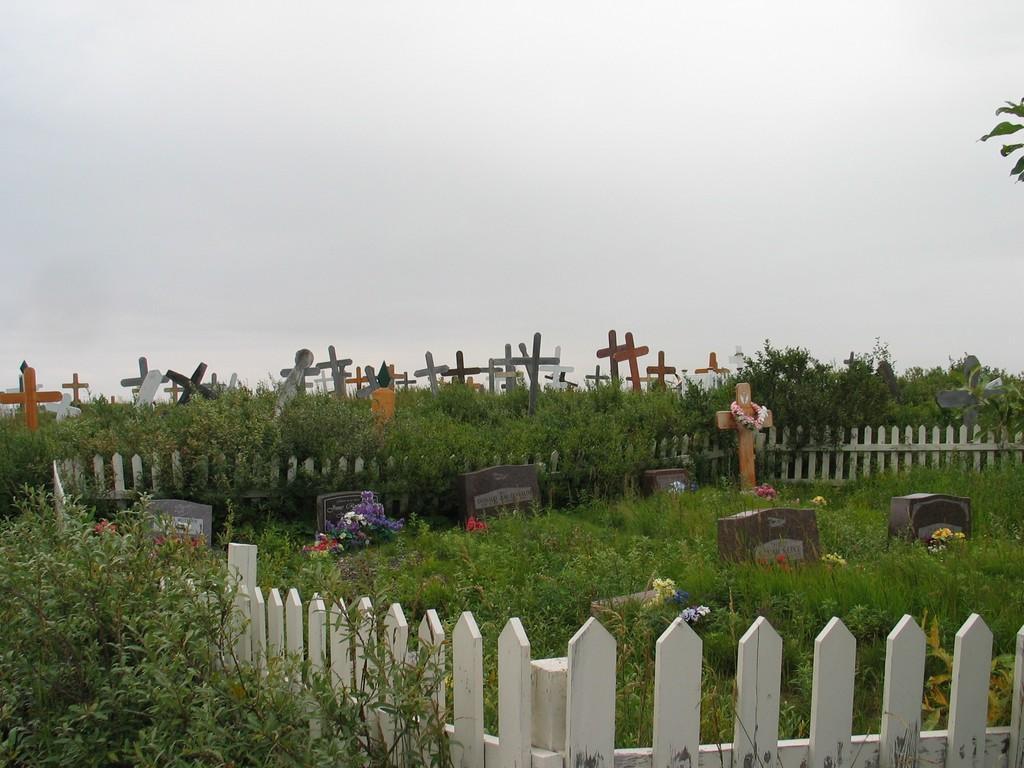Could you give a brief overview of what you see in this image? This is a cemetery. In that there are many crosses. On that some flowers are kept. Also there are plants. In the background there is sky. 